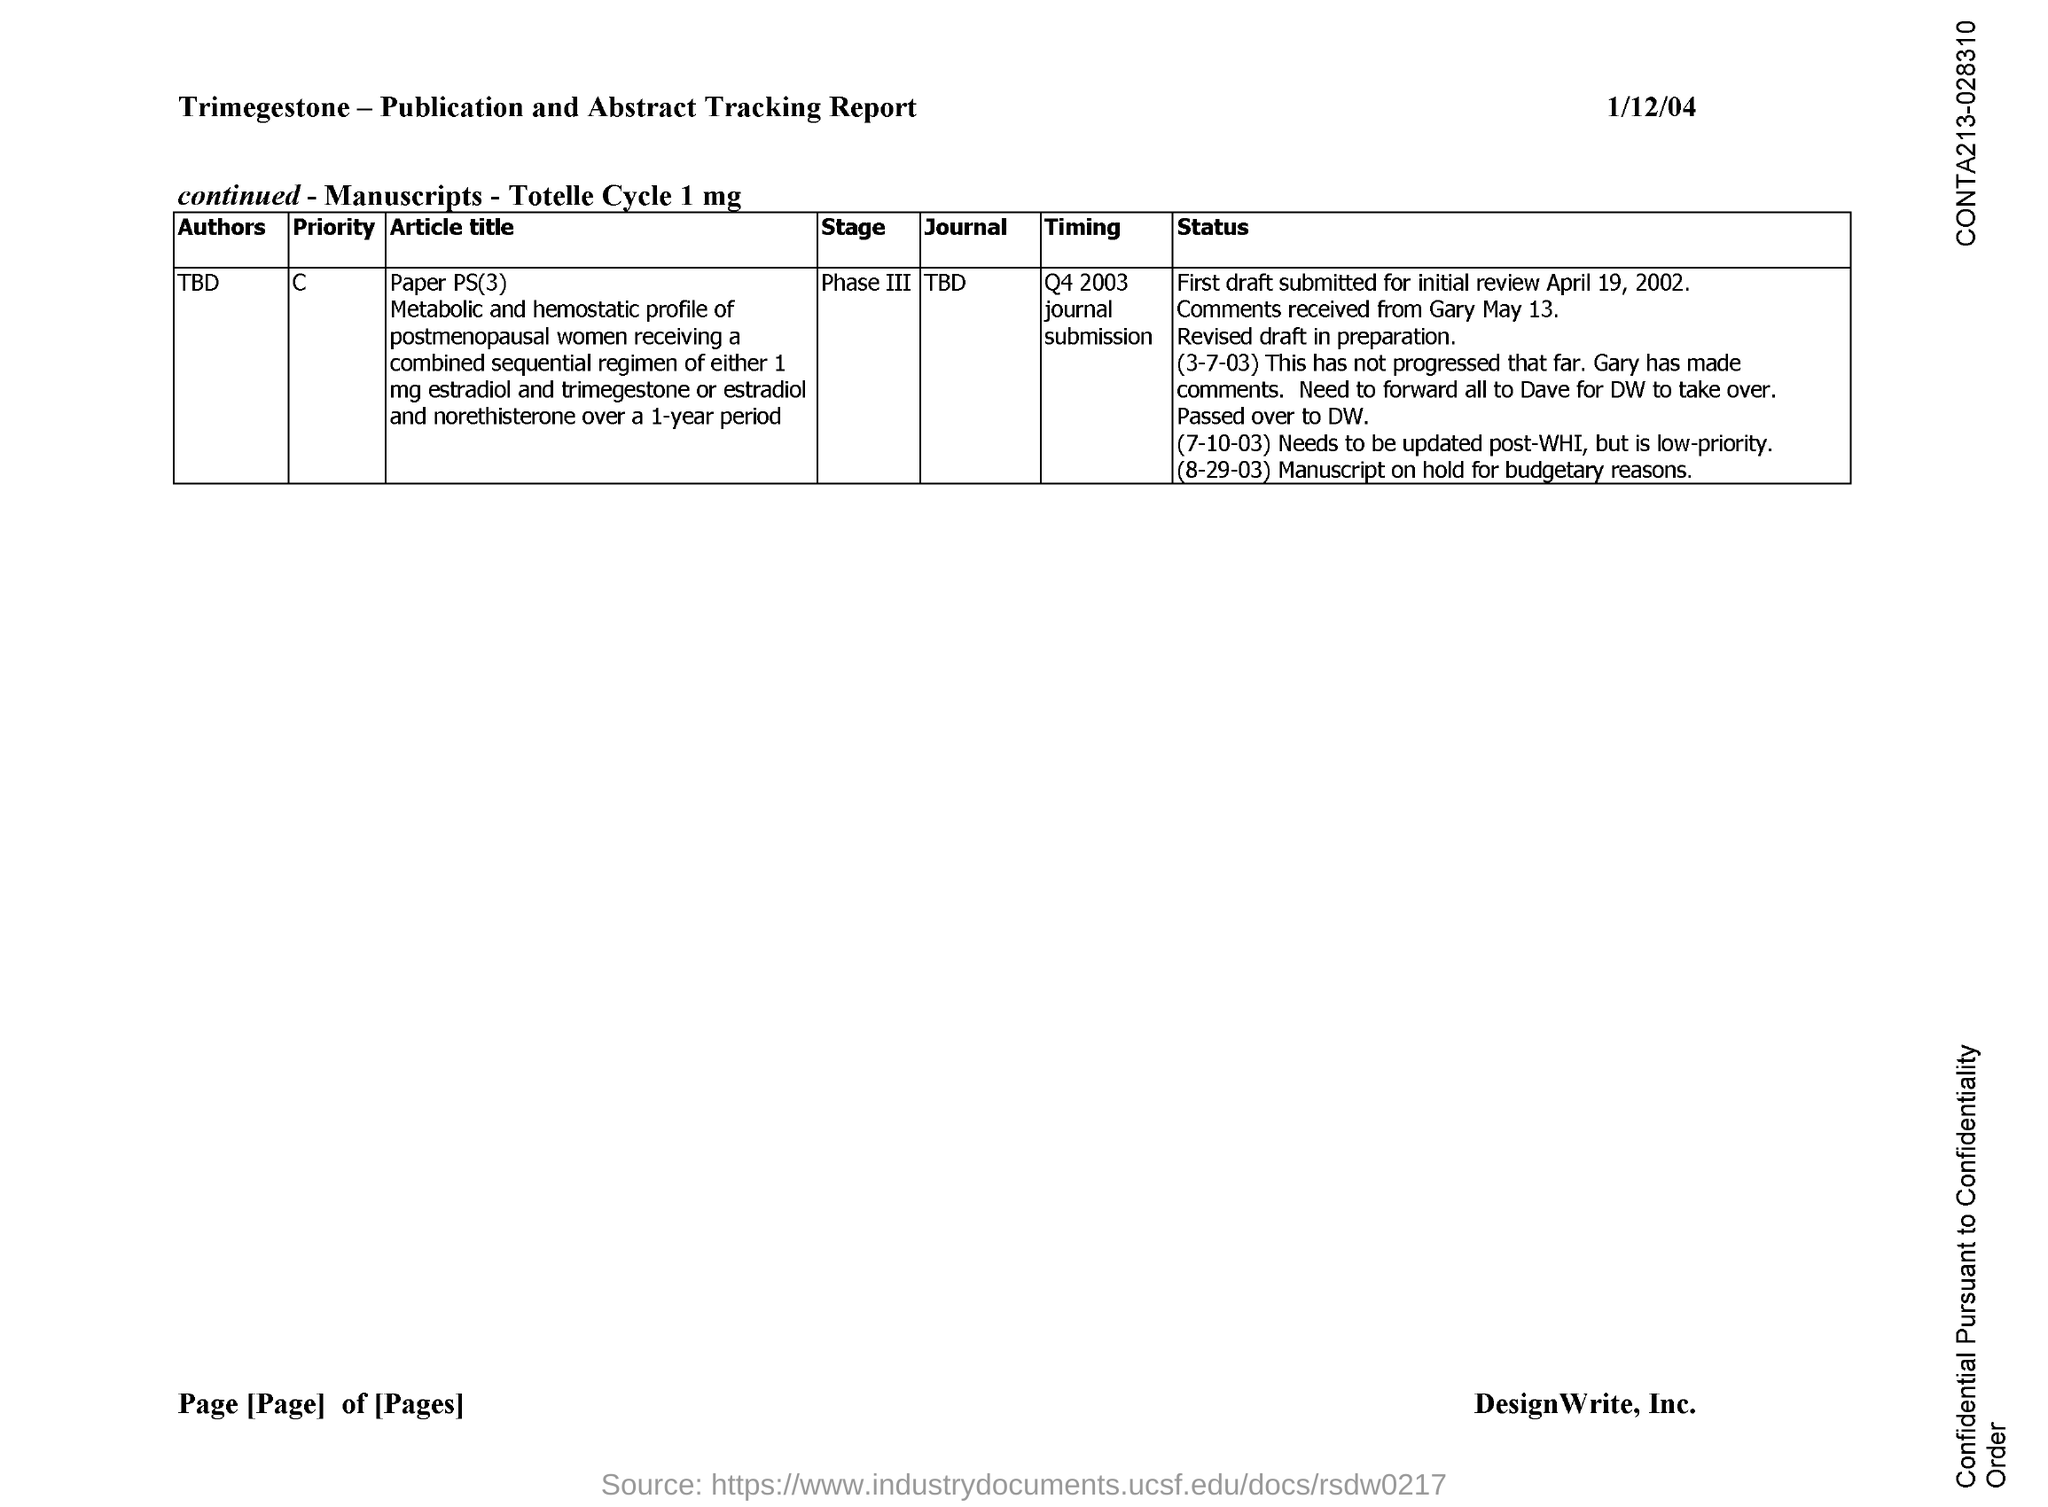Give some essential details in this illustration. I am not aware of a specific document with the information provided. The name of the author for Paper PS(3) has not been specified yet. The timing for Paper PS(3) was q4 2003. 